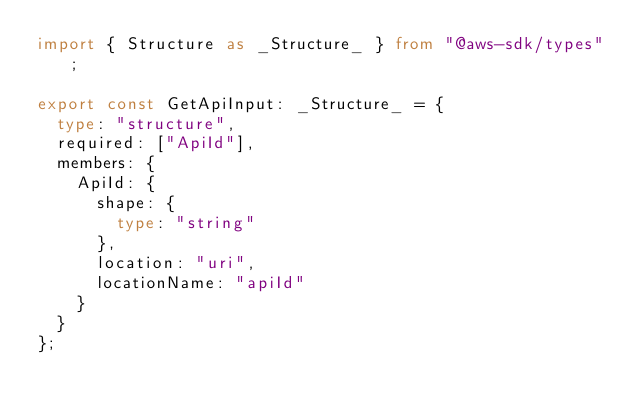Convert code to text. <code><loc_0><loc_0><loc_500><loc_500><_TypeScript_>import { Structure as _Structure_ } from "@aws-sdk/types";

export const GetApiInput: _Structure_ = {
  type: "structure",
  required: ["ApiId"],
  members: {
    ApiId: {
      shape: {
        type: "string"
      },
      location: "uri",
      locationName: "apiId"
    }
  }
};
</code> 